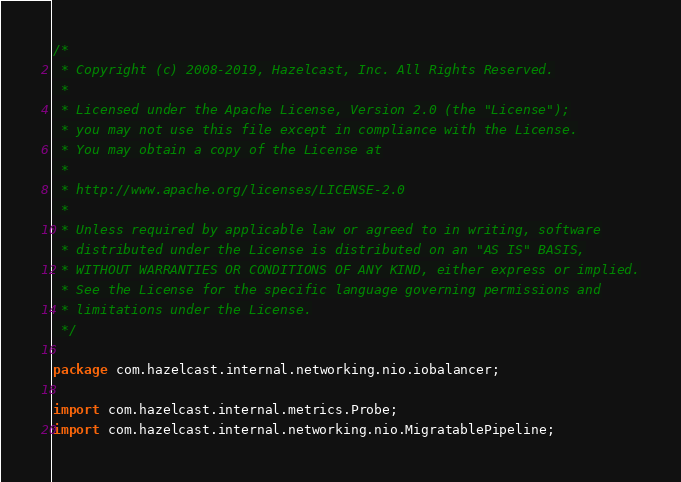<code> <loc_0><loc_0><loc_500><loc_500><_Java_>/*
 * Copyright (c) 2008-2019, Hazelcast, Inc. All Rights Reserved.
 *
 * Licensed under the Apache License, Version 2.0 (the "License");
 * you may not use this file except in compliance with the License.
 * You may obtain a copy of the License at
 *
 * http://www.apache.org/licenses/LICENSE-2.0
 *
 * Unless required by applicable law or agreed to in writing, software
 * distributed under the License is distributed on an "AS IS" BASIS,
 * WITHOUT WARRANTIES OR CONDITIONS OF ANY KIND, either express or implied.
 * See the License for the specific language governing permissions and
 * limitations under the License.
 */

package com.hazelcast.internal.networking.nio.iobalancer;

import com.hazelcast.internal.metrics.Probe;
import com.hazelcast.internal.networking.nio.MigratablePipeline;</code> 